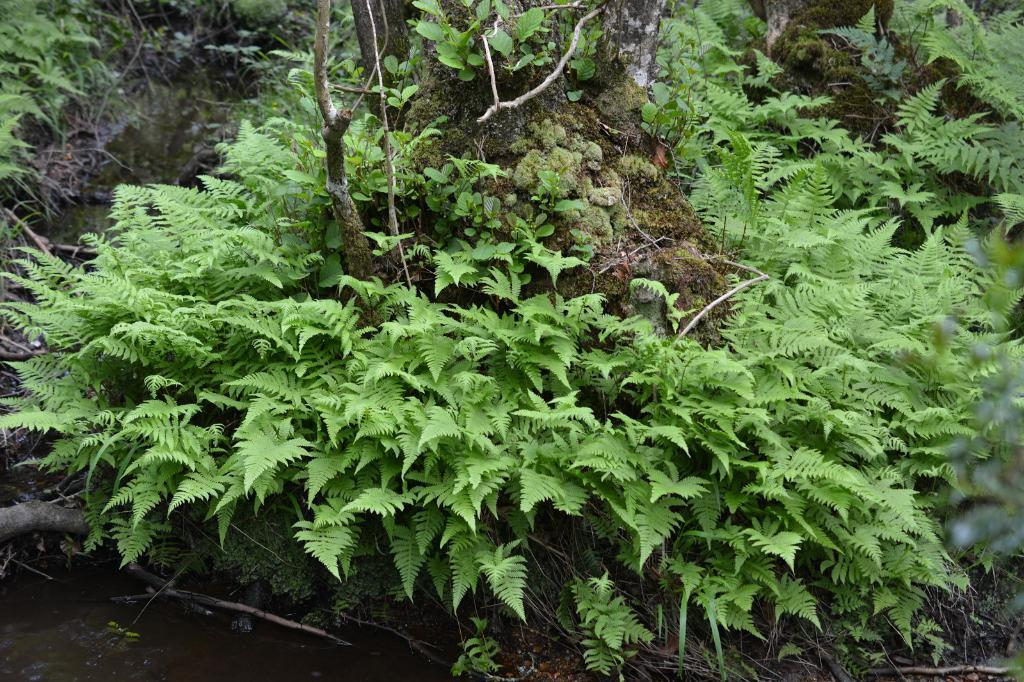What color are the trees in the image? The trees in the image are green in color. How many members are on the team that is playing in the wilderness in the image? There is no team or wilderness present in the image; it only features green trees. 